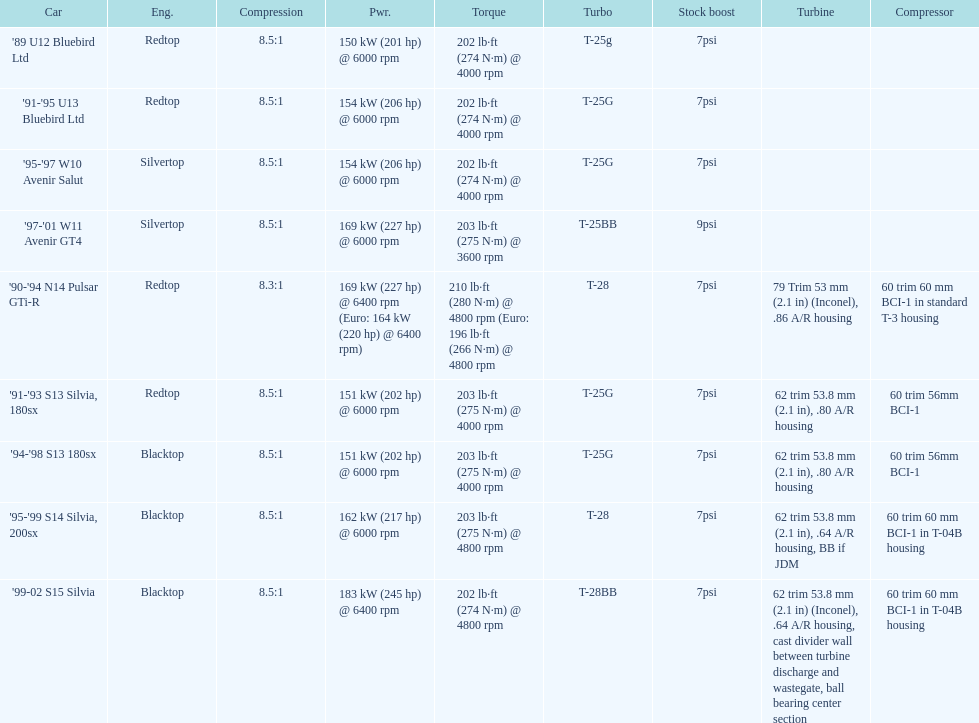What cars are there? '89 U12 Bluebird Ltd, 7psi, '91-'95 U13 Bluebird Ltd, 7psi, '95-'97 W10 Avenir Salut, 7psi, '97-'01 W11 Avenir GT4, 9psi, '90-'94 N14 Pulsar GTi-R, 7psi, '91-'93 S13 Silvia, 180sx, 7psi, '94-'98 S13 180sx, 7psi, '95-'99 S14 Silvia, 200sx, 7psi, '99-02 S15 Silvia, 7psi. Which stock boost is over 7psi? '97-'01 W11 Avenir GT4, 9psi. What car is it? '97-'01 W11 Avenir GT4. 